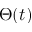<formula> <loc_0><loc_0><loc_500><loc_500>\Theta ( t )</formula> 